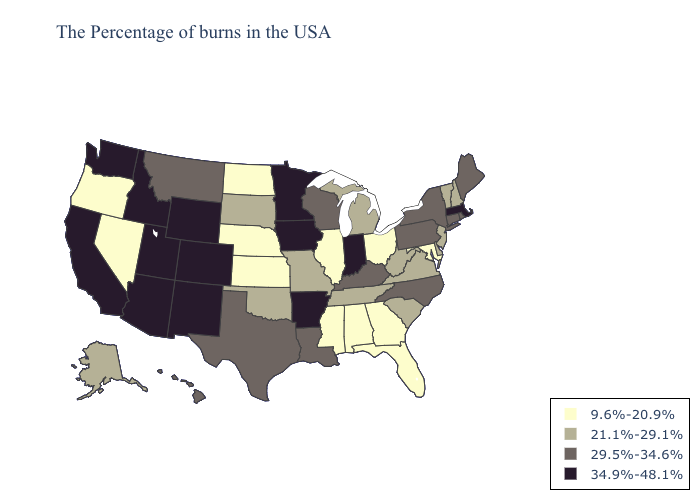Does West Virginia have the lowest value in the South?
Answer briefly. No. Name the states that have a value in the range 29.5%-34.6%?
Short answer required. Maine, Rhode Island, Connecticut, New York, Pennsylvania, North Carolina, Kentucky, Wisconsin, Louisiana, Texas, Montana, Hawaii. What is the lowest value in the South?
Be succinct. 9.6%-20.9%. What is the value of Louisiana?
Keep it brief. 29.5%-34.6%. Which states have the lowest value in the MidWest?
Quick response, please. Ohio, Illinois, Kansas, Nebraska, North Dakota. Does Massachusetts have the highest value in the USA?
Short answer required. Yes. Does Colorado have the same value as Michigan?
Short answer required. No. What is the lowest value in states that border Florida?
Concise answer only. 9.6%-20.9%. What is the value of New York?
Keep it brief. 29.5%-34.6%. Name the states that have a value in the range 9.6%-20.9%?
Short answer required. Maryland, Ohio, Florida, Georgia, Alabama, Illinois, Mississippi, Kansas, Nebraska, North Dakota, Nevada, Oregon. What is the highest value in states that border Arizona?
Answer briefly. 34.9%-48.1%. Does Arizona have the lowest value in the USA?
Be succinct. No. Which states have the highest value in the USA?
Quick response, please. Massachusetts, Indiana, Arkansas, Minnesota, Iowa, Wyoming, Colorado, New Mexico, Utah, Arizona, Idaho, California, Washington. What is the value of Hawaii?
Short answer required. 29.5%-34.6%. Does New Hampshire have the lowest value in the Northeast?
Answer briefly. Yes. 